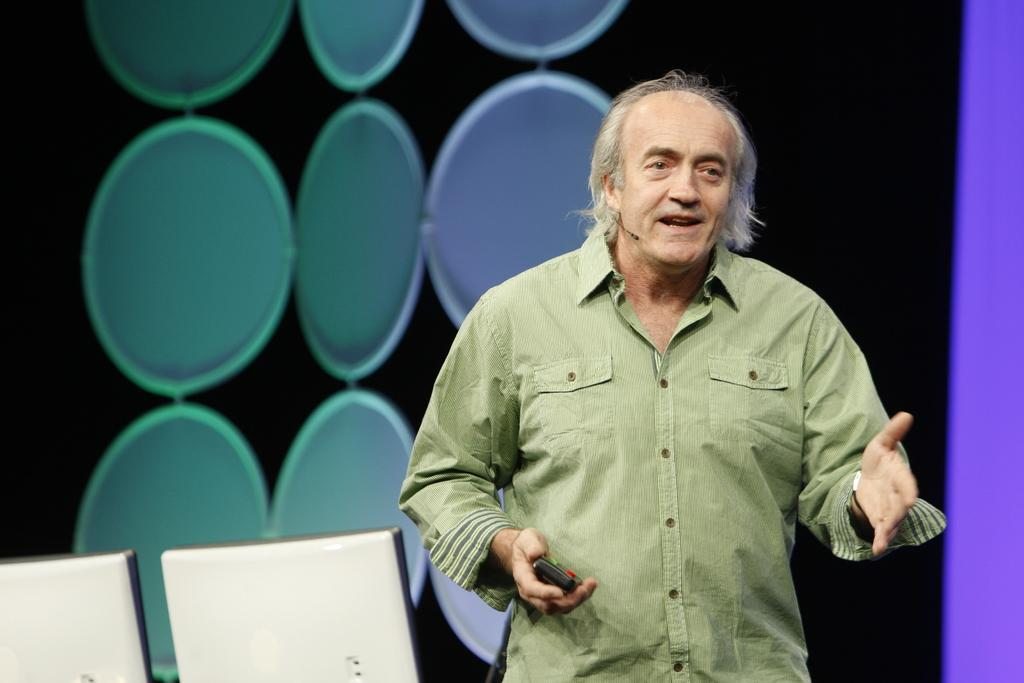What color is the shirt worn by the person in the image? The person in the image is wearing a green shirt. What is the person holding in his hand? The person is holding a remote in his hand. How many monitors are visible at the bottom of the image? There are two monitors at the bottom of the image. What can be seen on the wall behind the person? There is a wall with paintings behind the person. What type of letter is the person reading in the image? There is no letter present in the image; the person is holding a remote in his hand. 